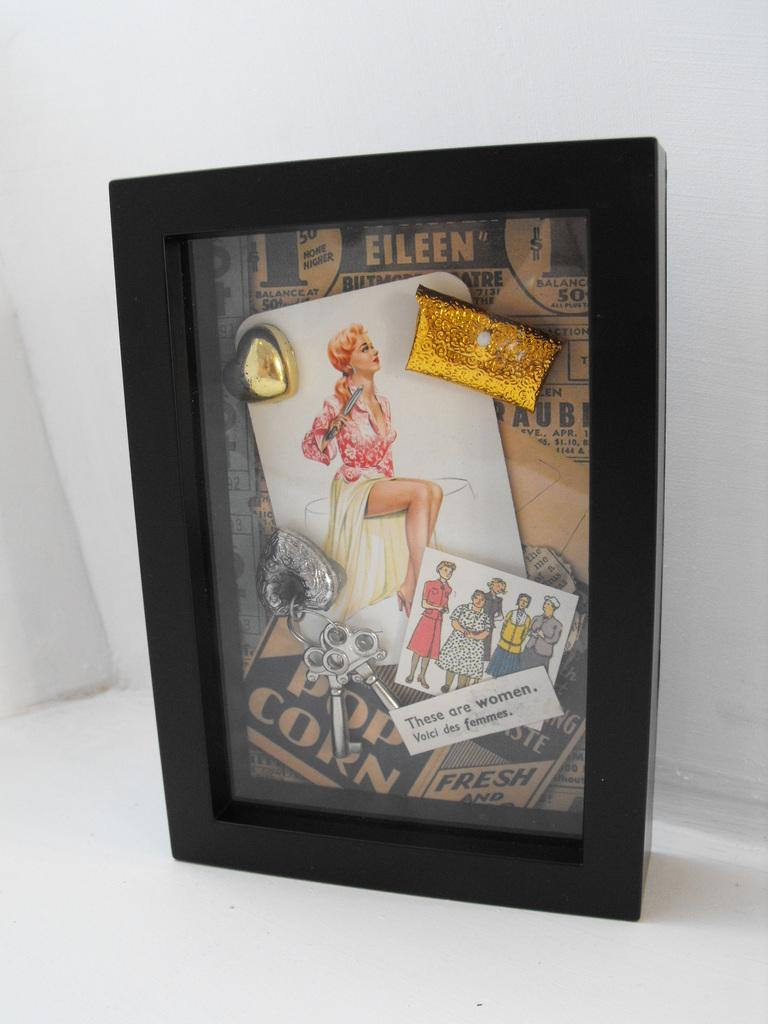<image>
Write a terse but informative summary of the picture. a framed picture that says 'these are women. boici des femmes.' 